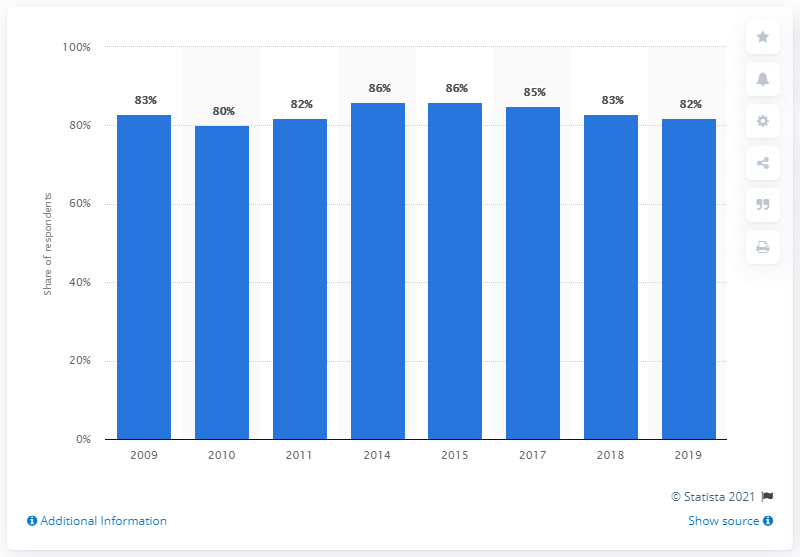Draw attention to some important aspects in this diagram. In 2015, approximately 86% of the population were book readers. According to the survey, 82% of Swedish respondents reported having read books at least once in the past year. 